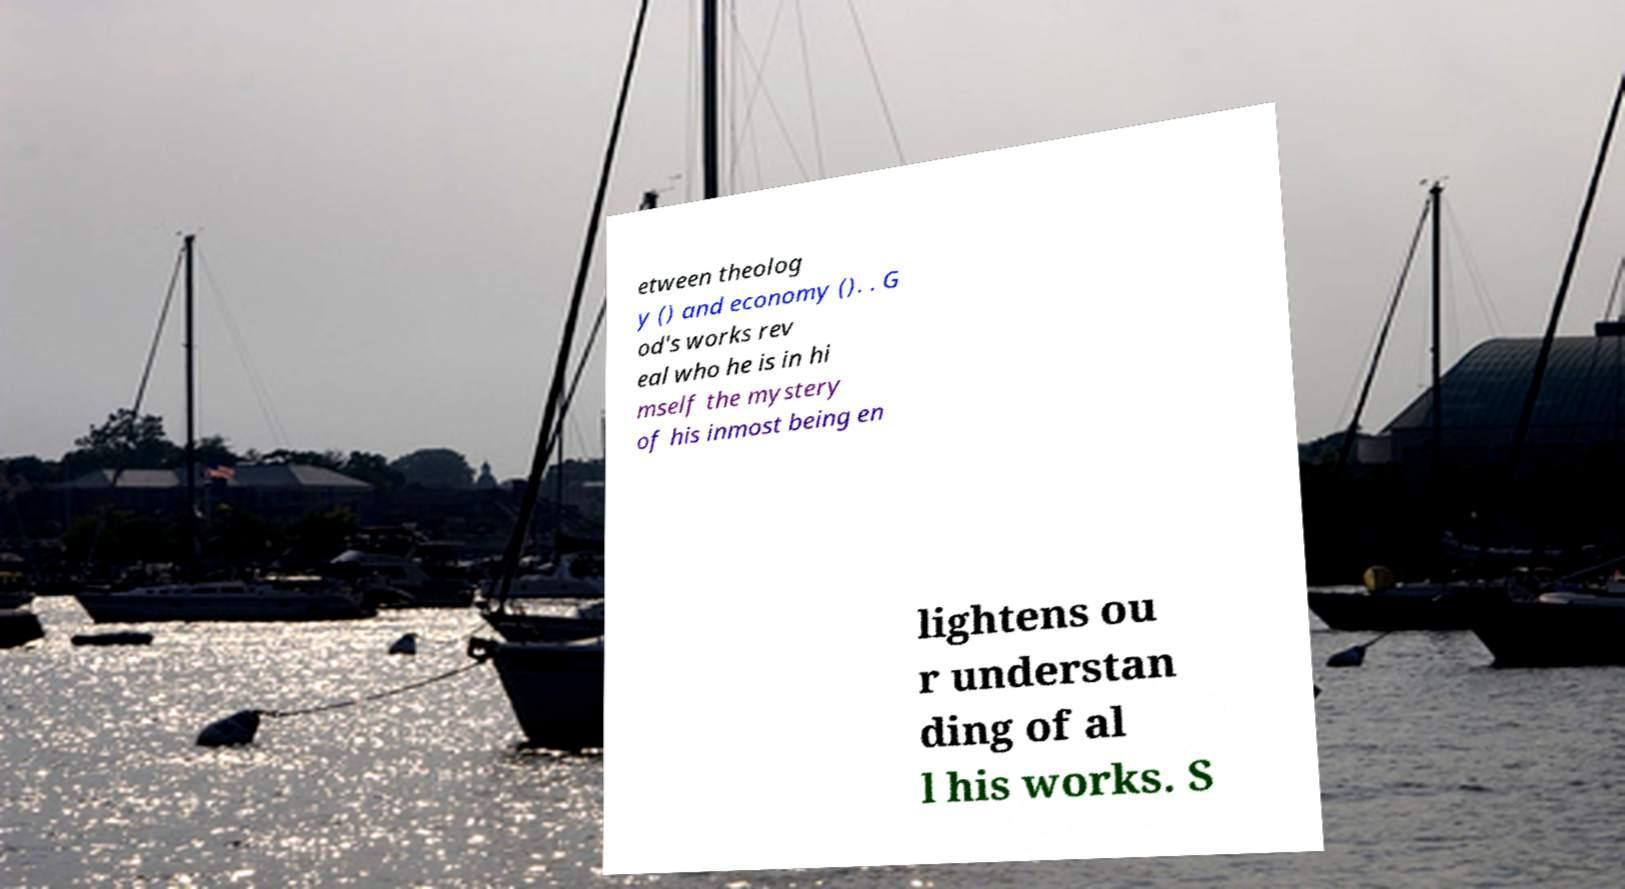Can you accurately transcribe the text from the provided image for me? etween theolog y () and economy (). . G od's works rev eal who he is in hi mself the mystery of his inmost being en lightens ou r understan ding of al l his works. S 